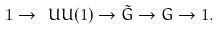<formula> <loc_0><loc_0><loc_500><loc_500>1 \rightarrow \ U U ( 1 ) \rightarrow { \tilde { G } } \rightarrow G \rightarrow 1 .</formula> 